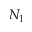<formula> <loc_0><loc_0><loc_500><loc_500>N _ { 1 }</formula> 